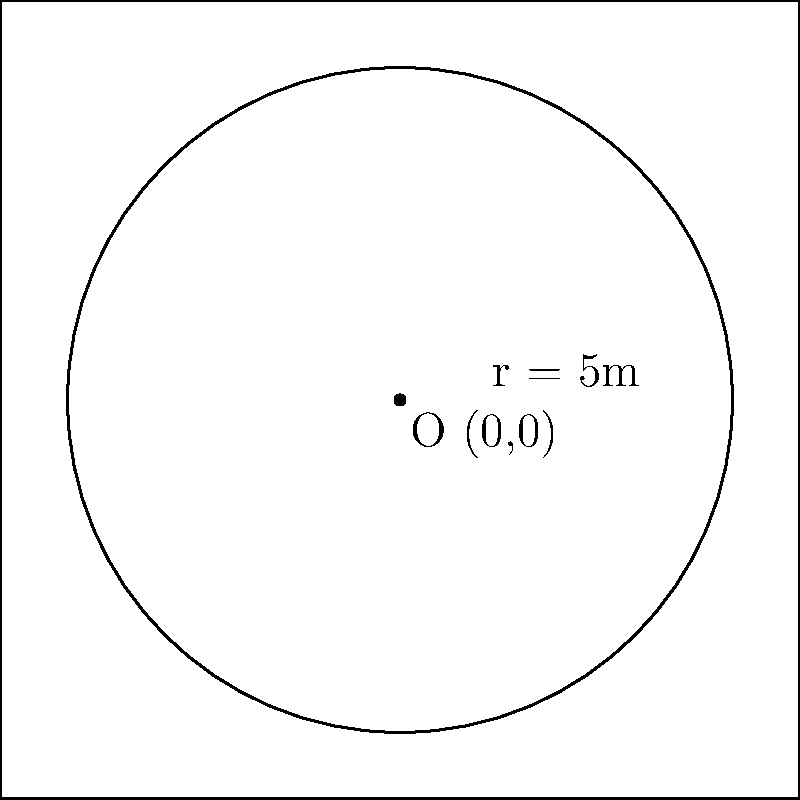In the circular isolation ward at Park Prewett Hospital, the center of the ward is located at coordinates (0,0) and has a radius of 5 meters. Calculate the area of this isolation ward. To calculate the area of the circular isolation ward, we need to use the formula for the area of a circle:

$$A = \pi r^2$$

Where:
$A$ is the area of the circle
$\pi$ is approximately 3.14159
$r$ is the radius of the circle

Given:
- The center of the ward is at (0,0)
- The radius is 5 meters

Step 1: Substitute the radius into the formula
$$A = \pi (5)^2$$

Step 2: Calculate the square of the radius
$$A = \pi (25)$$

Step 3: Multiply by π
$$A = 78.53975... \text{ square meters}$$

Step 4: Round to two decimal places
$$A \approx 78.54 \text{ square meters}$$
Answer: 78.54 m² 